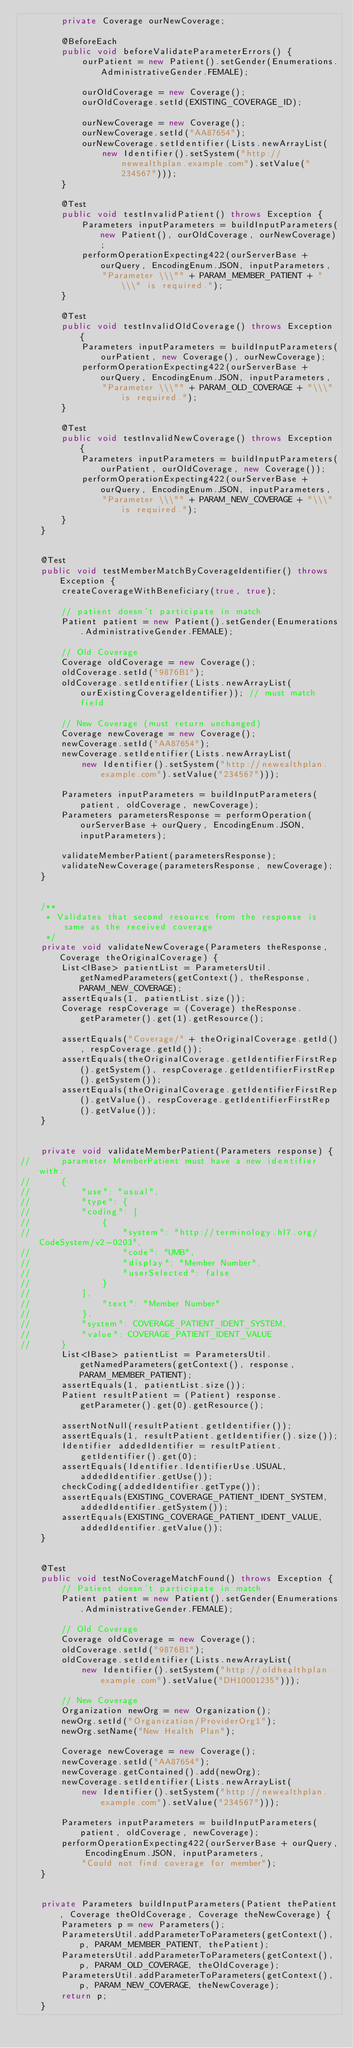<code> <loc_0><loc_0><loc_500><loc_500><_Java_>		private Coverage ourNewCoverage;

		@BeforeEach
		public void beforeValidateParameterErrors() {
			ourPatient = new Patient().setGender(Enumerations.AdministrativeGender.FEMALE);

			ourOldCoverage = new Coverage();
			ourOldCoverage.setId(EXISTING_COVERAGE_ID);

			ourNewCoverage = new Coverage();
			ourNewCoverage.setId("AA87654");
			ourNewCoverage.setIdentifier(Lists.newArrayList(
				new Identifier().setSystem("http://newealthplan.example.com").setValue("234567")));
		}

		@Test
		public void testInvalidPatient() throws Exception {
			Parameters inputParameters = buildInputParameters(new Patient(), ourOldCoverage, ourNewCoverage);
			performOperationExpecting422(ourServerBase + ourQuery, EncodingEnum.JSON, inputParameters,
				"Parameter \\\"" + PARAM_MEMBER_PATIENT + "\\\" is required.");
		}

		@Test
		public void testInvalidOldCoverage() throws Exception {
			Parameters inputParameters = buildInputParameters(ourPatient, new Coverage(), ourNewCoverage);
			performOperationExpecting422(ourServerBase + ourQuery, EncodingEnum.JSON, inputParameters,
				"Parameter \\\"" + PARAM_OLD_COVERAGE + "\\\" is required.");
		}

		@Test
		public void testInvalidNewCoverage() throws Exception {
			Parameters inputParameters = buildInputParameters(ourPatient, ourOldCoverage, new Coverage());
			performOperationExpecting422(ourServerBase + ourQuery, EncodingEnum.JSON, inputParameters,
				"Parameter \\\"" + PARAM_NEW_COVERAGE + "\\\" is required.");
		}
	}


	@Test
	public void testMemberMatchByCoverageIdentifier() throws Exception {
		createCoverageWithBeneficiary(true, true);

		// patient doesn't participate in match
		Patient patient = new Patient().setGender(Enumerations.AdministrativeGender.FEMALE);

		// Old Coverage
		Coverage oldCoverage = new Coverage();
		oldCoverage.setId("9876B1");
		oldCoverage.setIdentifier(Lists.newArrayList(ourExistingCoverageIdentifier)); // must match field

		// New Coverage (must return unchanged)
		Coverage newCoverage = new Coverage();
		newCoverage.setId("AA87654");
		newCoverage.setIdentifier(Lists.newArrayList(
			new Identifier().setSystem("http://newealthplan.example.com").setValue("234567")));

		Parameters inputParameters = buildInputParameters(patient, oldCoverage, newCoverage);
		Parameters parametersResponse = performOperation(ourServerBase + ourQuery, EncodingEnum.JSON, inputParameters);

		validateMemberPatient(parametersResponse);
		validateNewCoverage(parametersResponse, newCoverage);
	}


	/**
	 * Validates that second resource from the response is same as the received coverage
	 */
	private void validateNewCoverage(Parameters theResponse, Coverage theOriginalCoverage) {
		List<IBase> patientList = ParametersUtil.getNamedParameters(getContext(), theResponse, PARAM_NEW_COVERAGE);
		assertEquals(1, patientList.size());
		Coverage respCoverage = (Coverage) theResponse.getParameter().get(1).getResource();

		assertEquals("Coverage/" + theOriginalCoverage.getId(), respCoverage.getId());
		assertEquals(theOriginalCoverage.getIdentifierFirstRep().getSystem(), respCoverage.getIdentifierFirstRep().getSystem());
		assertEquals(theOriginalCoverage.getIdentifierFirstRep().getValue(), respCoverage.getIdentifierFirstRep().getValue());
	}


	private void validateMemberPatient(Parameters response) {
//		parameter MemberPatient must have a new identifier with:
//		{
//			"use": "usual",
//			"type": {
//			"coding": [
//				{
//					"system": "http://terminology.hl7.org/CodeSystem/v2-0203",
//					"code": "UMB",
//					"display": "Member Number",
//					"userSelected": false
//				}
//       	],
//				"text": "Member Number"
//			},
//			"system": COVERAGE_PATIENT_IDENT_SYSTEM,
//			"value": COVERAGE_PATIENT_IDENT_VALUE
//		}
		List<IBase> patientList = ParametersUtil.getNamedParameters(getContext(), response, PARAM_MEMBER_PATIENT);
		assertEquals(1, patientList.size());
		Patient resultPatient = (Patient) response.getParameter().get(0).getResource();

		assertNotNull(resultPatient.getIdentifier());
		assertEquals(1, resultPatient.getIdentifier().size());
		Identifier addedIdentifier = resultPatient.getIdentifier().get(0);
		assertEquals(Identifier.IdentifierUse.USUAL, addedIdentifier.getUse());
		checkCoding(addedIdentifier.getType());
		assertEquals(EXISTING_COVERAGE_PATIENT_IDENT_SYSTEM, addedIdentifier.getSystem());
		assertEquals(EXISTING_COVERAGE_PATIENT_IDENT_VALUE, addedIdentifier.getValue());
	}


	@Test
	public void testNoCoverageMatchFound() throws Exception {
		// Patient doesn't participate in match
		Patient patient = new Patient().setGender(Enumerations.AdministrativeGender.FEMALE);

		// Old Coverage
		Coverage oldCoverage = new Coverage();
		oldCoverage.setId("9876B1");
		oldCoverage.setIdentifier(Lists.newArrayList(
			new Identifier().setSystem("http://oldhealthplan.example.com").setValue("DH10001235")));

		// New Coverage
		Organization newOrg = new Organization();
		newOrg.setId("Organization/ProviderOrg1");
		newOrg.setName("New Health Plan");

		Coverage newCoverage = new Coverage();
		newCoverage.setId("AA87654");
		newCoverage.getContained().add(newOrg);
		newCoverage.setIdentifier(Lists.newArrayList(
			new Identifier().setSystem("http://newealthplan.example.com").setValue("234567")));

		Parameters inputParameters = buildInputParameters(patient, oldCoverage, newCoverage);
		performOperationExpecting422(ourServerBase + ourQuery, EncodingEnum.JSON, inputParameters,
			"Could not find coverage for member");
	}


	private Parameters buildInputParameters(Patient thePatient, Coverage theOldCoverage, Coverage theNewCoverage) {
		Parameters p = new Parameters();
		ParametersUtil.addParameterToParameters(getContext(), p, PARAM_MEMBER_PATIENT, thePatient);
		ParametersUtil.addParameterToParameters(getContext(), p, PARAM_OLD_COVERAGE, theOldCoverage);
		ParametersUtil.addParameterToParameters(getContext(), p, PARAM_NEW_COVERAGE, theNewCoverage);
		return p;
	}

</code> 